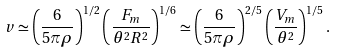<formula> <loc_0><loc_0><loc_500><loc_500>v \simeq \left ( \frac { 6 } { 5 \pi \rho } \right ) ^ { 1 / 2 } \left ( \frac { F _ { m } } { \theta ^ { 2 } R ^ { 2 } } \right ) ^ { 1 / 6 } \simeq \left ( \frac { 6 } { 5 \pi \rho } \right ) ^ { 2 / 5 } \left ( \frac { V _ { m } } { \theta ^ { 2 } } \right ) ^ { 1 / 5 } .</formula> 